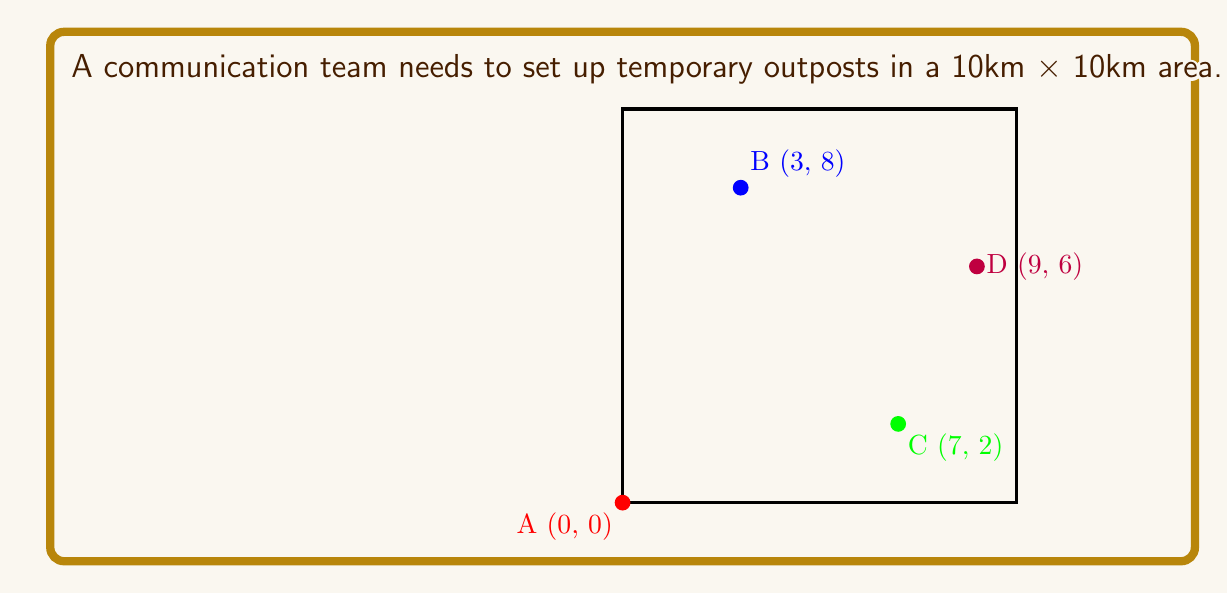Can you answer this question? To solve this problem, we need to use the Traveling Salesman Problem (TSP) approach:

1) First, calculate distances between all points using the Euclidean distance formula:
   $d = \sqrt{(x_2-x_1)^2 + (y_2-y_1)^2}$

   AB = $\sqrt{(3-0)^2 + (8-0)^2} = \sqrt{73} \approx 8.54$
   AC = $\sqrt{(7-0)^2 + (2-0)^2} = \sqrt{53} \approx 7.28$
   AD = $\sqrt{(9-0)^2 + (6-0)^2} = \sqrt{117} \approx 10.82$
   BC = $\sqrt{(7-3)^2 + (2-8)^2} = \sqrt{52} \approx 7.21$
   BD = $\sqrt{(9-3)^2 + (6-8)^2} = \sqrt{40} \approx 6.32$
   CD = $\sqrt{(9-7)^2 + (6-2)^2} = \sqrt{20} \approx 4.47$

2) There are 3! = 6 possible routes (excluding A-A):
   ABCDA, ABDCA, ACBDA, ACDBA, ADBCA, ADCBA

3) Calculate total distance for each route:
   ABCDA: 8.54 + 7.21 + 4.47 + 10.82 = 31.04
   ABDCA: 8.54 + 6.32 + 4.47 + 7.28 = 26.61
   ACBDA: 7.28 + 7.21 + 6.32 + 10.82 = 31.63
   ACDBA: 7.28 + 4.47 + 6.32 + 8.54 = 26.61
   ADBCA: 10.82 + 6.32 + 7.21 + 7.28 = 31.63
   ADCBA: 10.82 + 4.47 + 7.21 + 8.54 = 31.04

4) The routes ABDCA and ACDBA both give the minimum distance of 26.61 km.
Answer: 26.61 units of fuel (ABDCA or ACDBA route) 